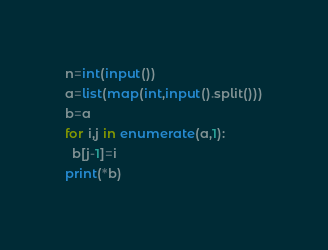<code> <loc_0><loc_0><loc_500><loc_500><_Python_>n=int(input())
a=list(map(int,input().split()))
b=a
for i,j in enumerate(a,1):
  b[j-1]=i
print(*b)
</code> 